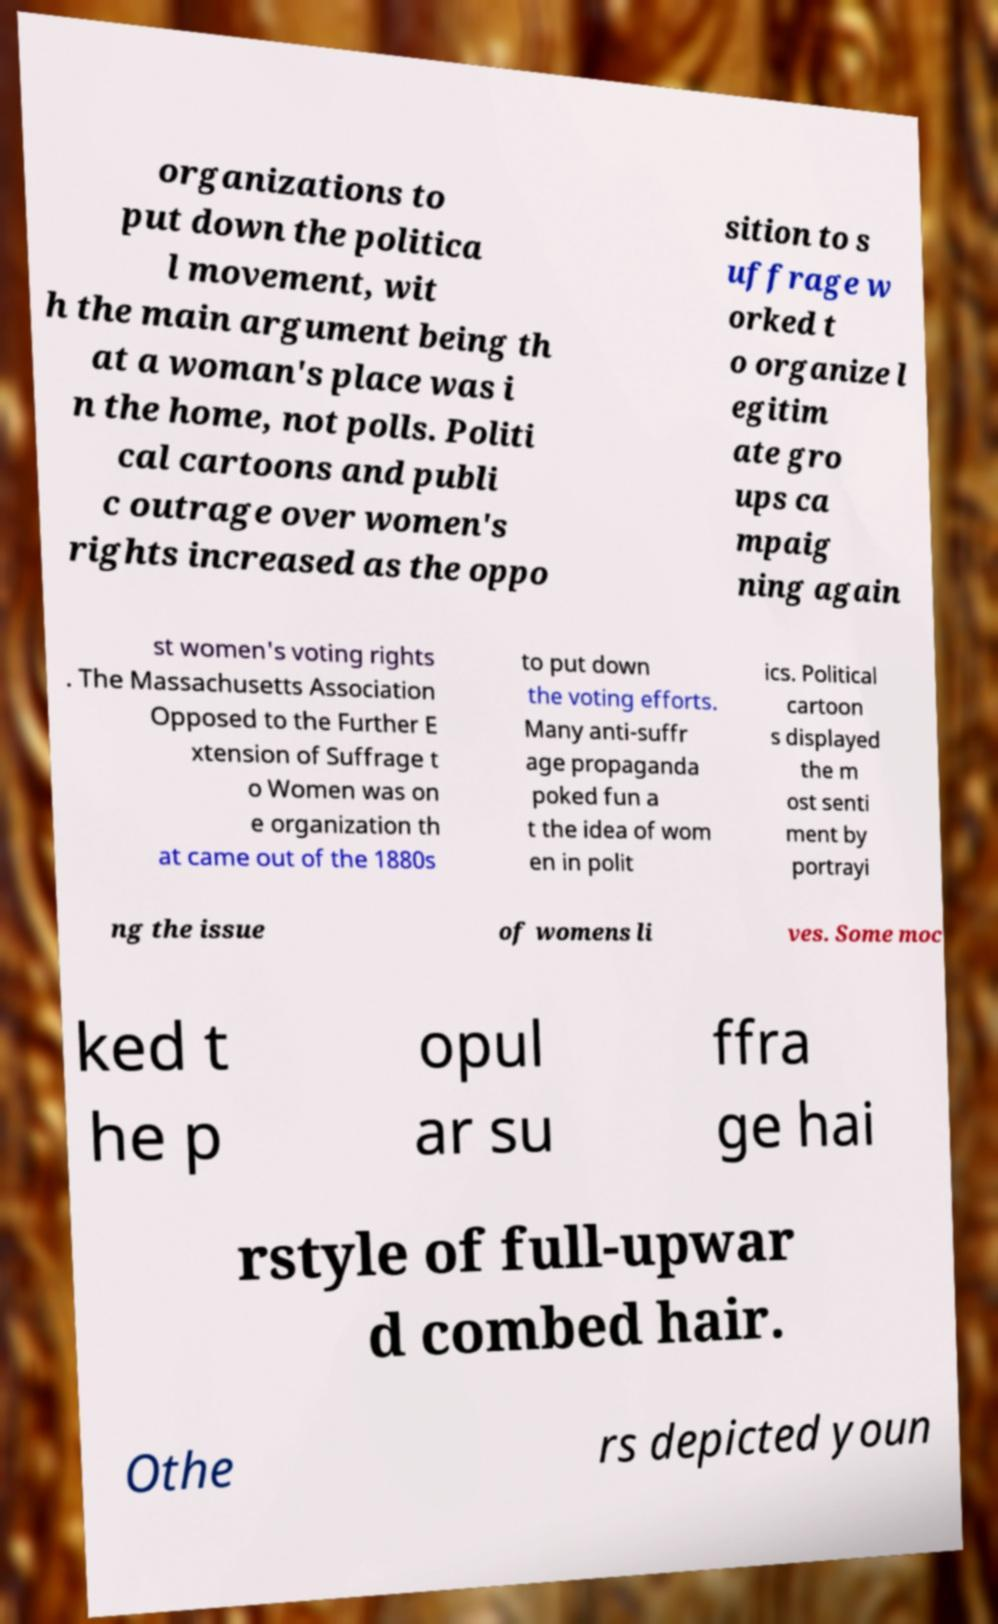There's text embedded in this image that I need extracted. Can you transcribe it verbatim? organizations to put down the politica l movement, wit h the main argument being th at a woman's place was i n the home, not polls. Politi cal cartoons and publi c outrage over women's rights increased as the oppo sition to s uffrage w orked t o organize l egitim ate gro ups ca mpaig ning again st women's voting rights . The Massachusetts Association Opposed to the Further E xtension of Suffrage t o Women was on e organization th at came out of the 1880s to put down the voting efforts. Many anti-suffr age propaganda poked fun a t the idea of wom en in polit ics. Political cartoon s displayed the m ost senti ment by portrayi ng the issue of womens li ves. Some moc ked t he p opul ar su ffra ge hai rstyle of full-upwar d combed hair. Othe rs depicted youn 